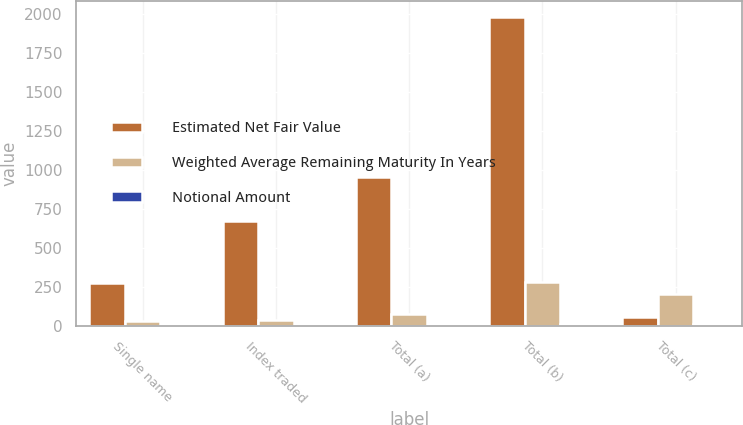Convert chart to OTSL. <chart><loc_0><loc_0><loc_500><loc_500><stacked_bar_chart><ecel><fcel>Single name<fcel>Index traded<fcel>Total (a)<fcel>Total (b)<fcel>Total (c)<nl><fcel>Estimated Net Fair Value<fcel>278<fcel>677<fcel>955<fcel>1982<fcel>61<nl><fcel>Weighted Average Remaining Maturity In Years<fcel>38<fcel>42<fcel>80<fcel>285<fcel>205<nl><fcel>Notional Amount<fcel>3.84<fcel>4.84<fcel>4.54<fcel>18.06<fcel>13.67<nl></chart> 